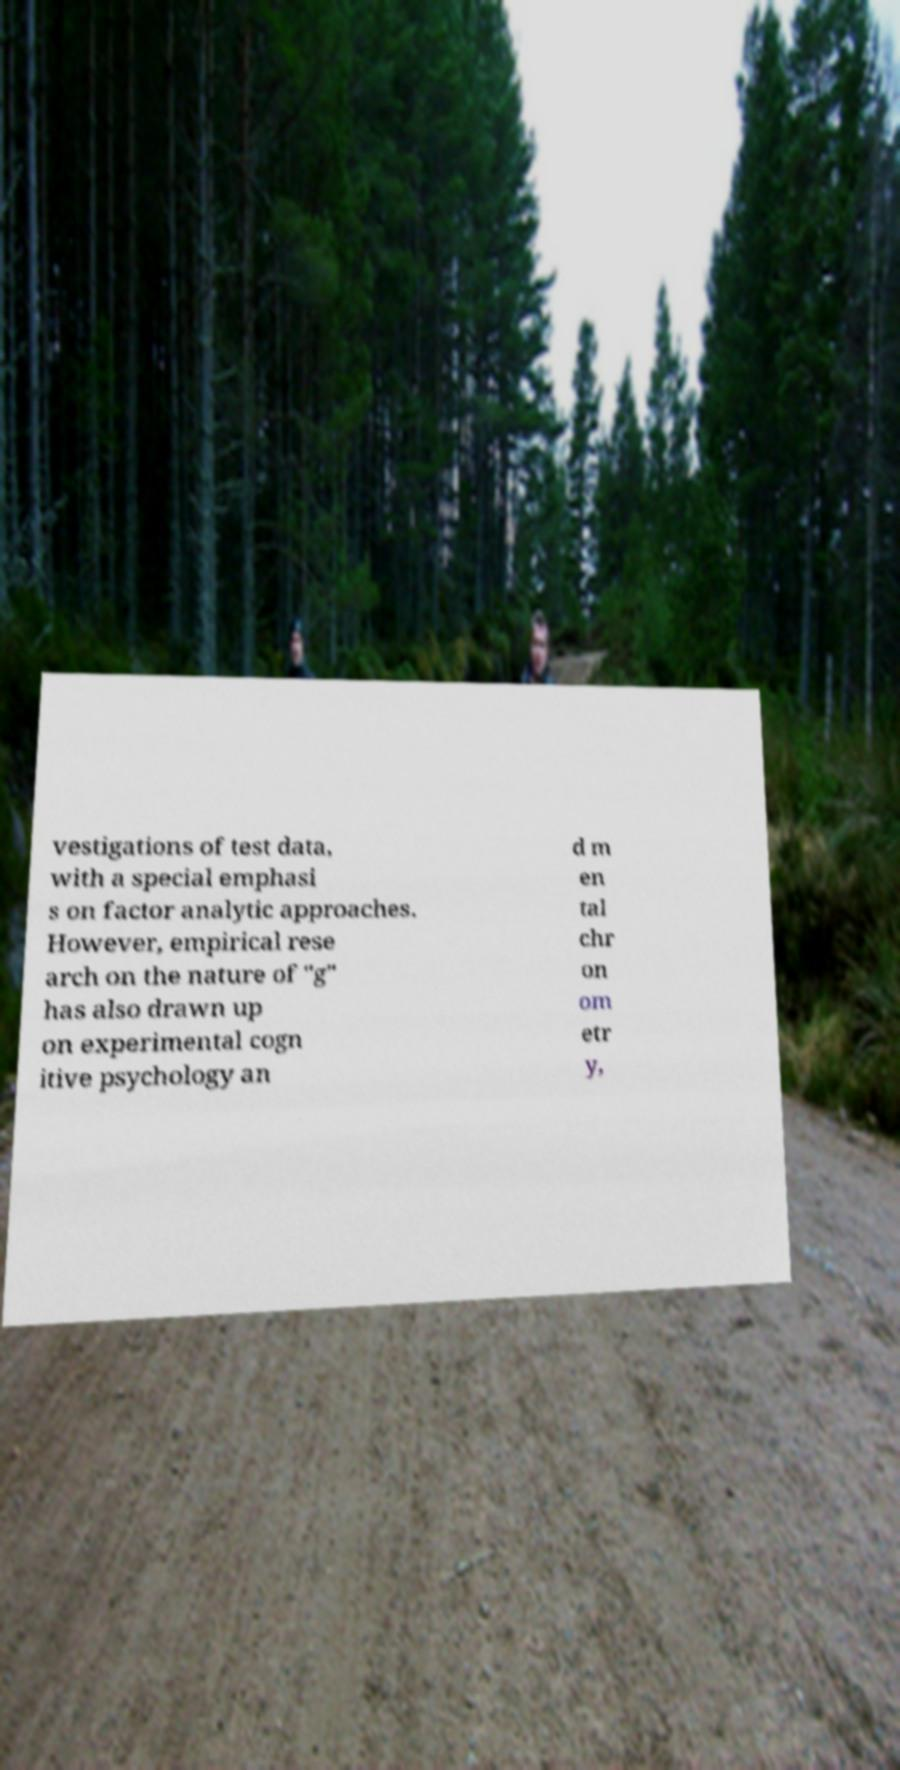Can you read and provide the text displayed in the image?This photo seems to have some interesting text. Can you extract and type it out for me? vestigations of test data, with a special emphasi s on factor analytic approaches. However, empirical rese arch on the nature of "g" has also drawn up on experimental cogn itive psychology an d m en tal chr on om etr y, 